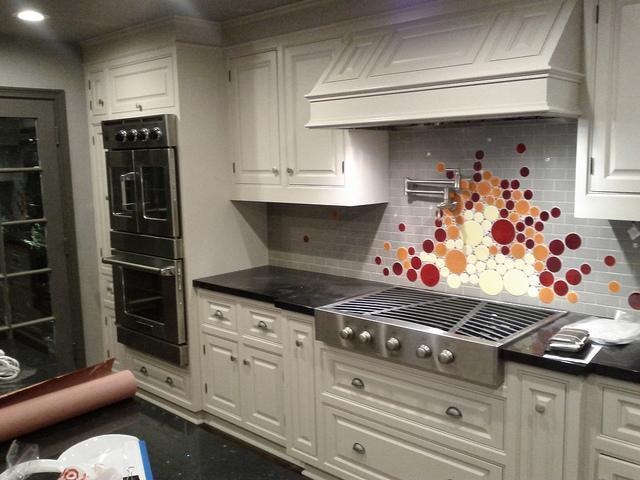How many ovens are in this kitchen?
Give a very brief answer. 2. How many ovens are there?
Give a very brief answer. 2. How many people are wearing blue shirts?
Give a very brief answer. 0. 